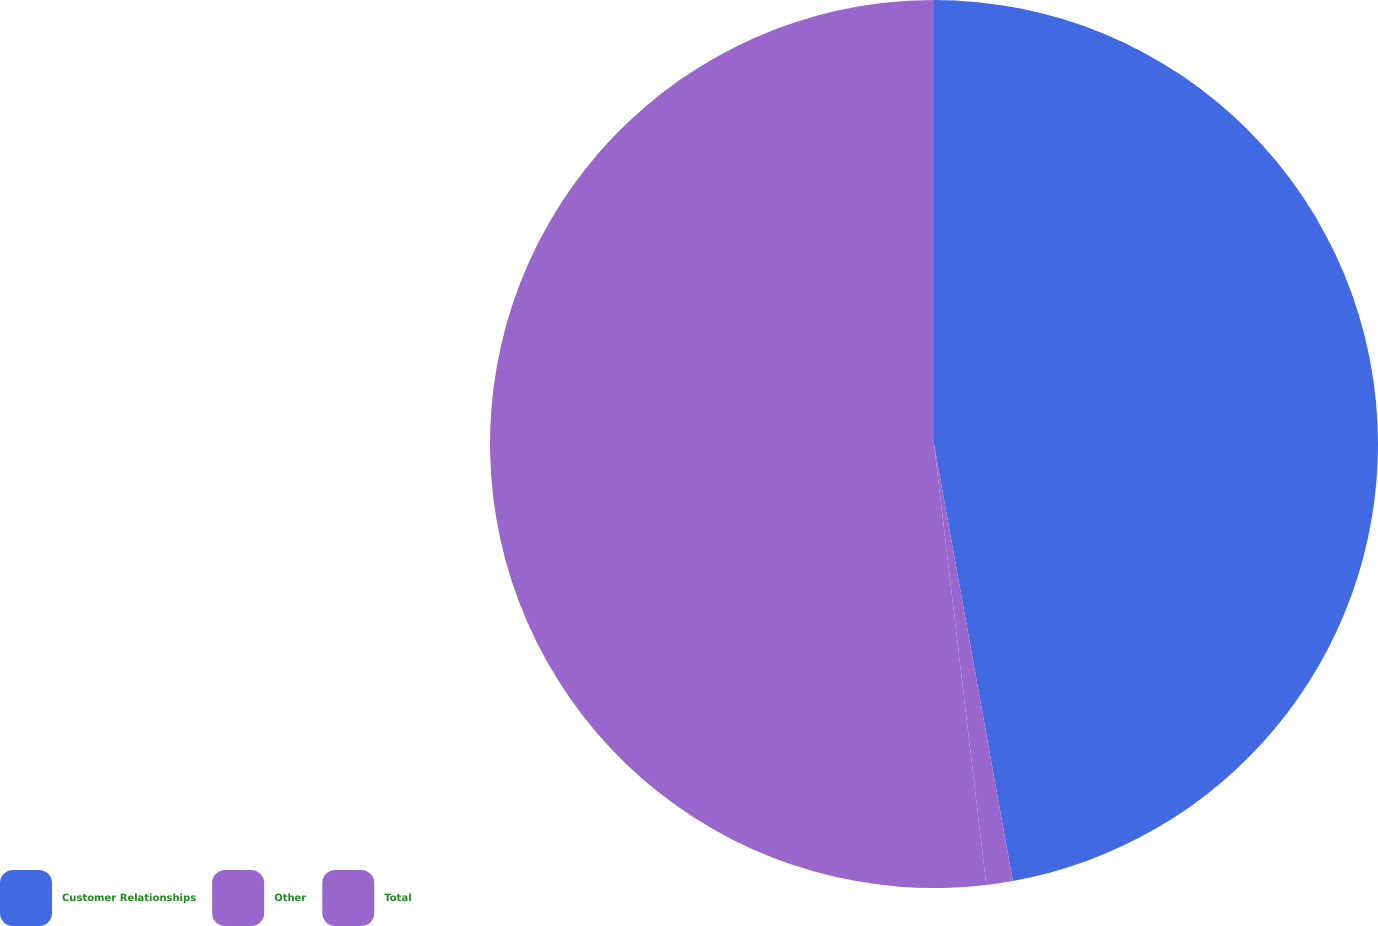<chart> <loc_0><loc_0><loc_500><loc_500><pie_chart><fcel>Customer Relationships<fcel>Other<fcel>Total<nl><fcel>47.16%<fcel>0.96%<fcel>51.88%<nl></chart> 